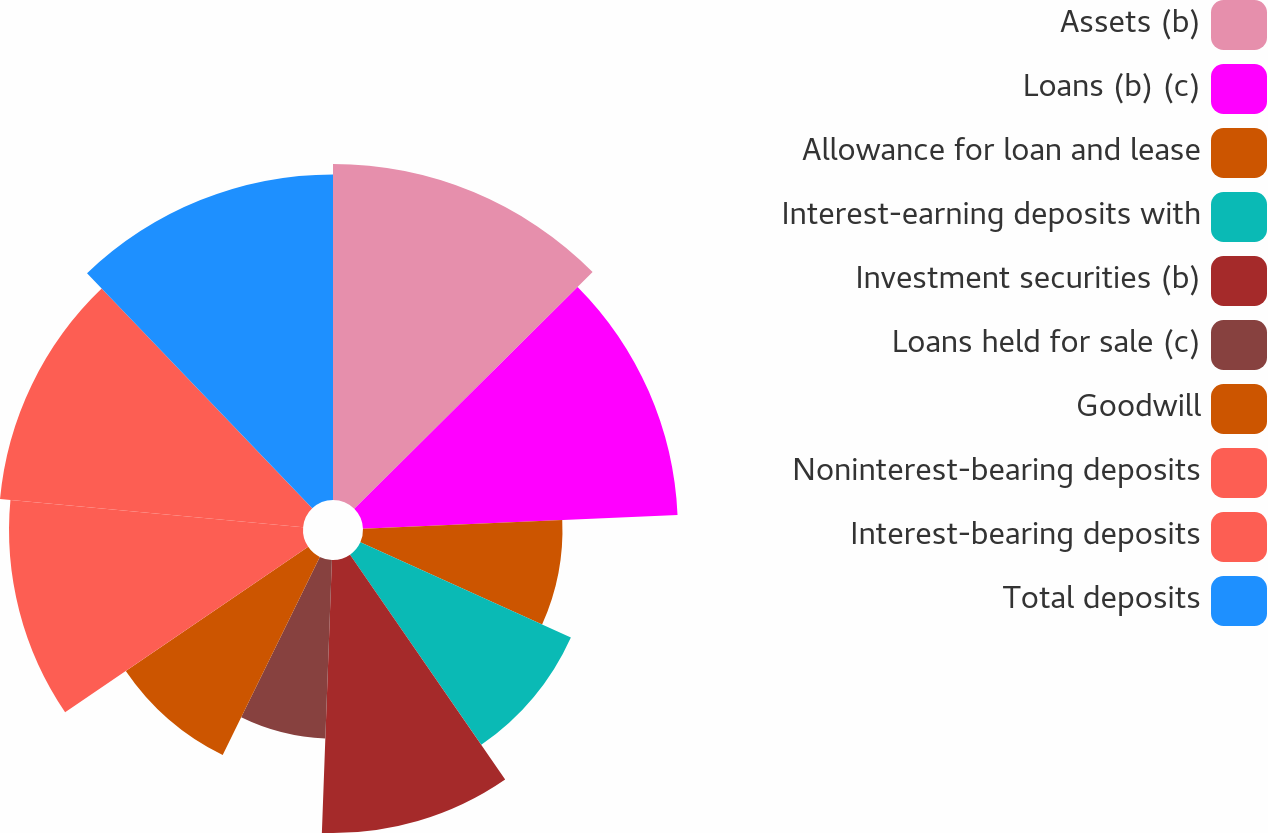Convert chart to OTSL. <chart><loc_0><loc_0><loc_500><loc_500><pie_chart><fcel>Assets (b)<fcel>Loans (b) (c)<fcel>Allowance for loan and lease<fcel>Interest-earning deposits with<fcel>Investment securities (b)<fcel>Loans held for sale (c)<fcel>Goodwill<fcel>Noninterest-bearing deposits<fcel>Interest-bearing deposits<fcel>Total deposits<nl><fcel>12.55%<fcel>11.76%<fcel>7.45%<fcel>8.63%<fcel>10.2%<fcel>6.67%<fcel>8.24%<fcel>10.98%<fcel>11.37%<fcel>12.16%<nl></chart> 